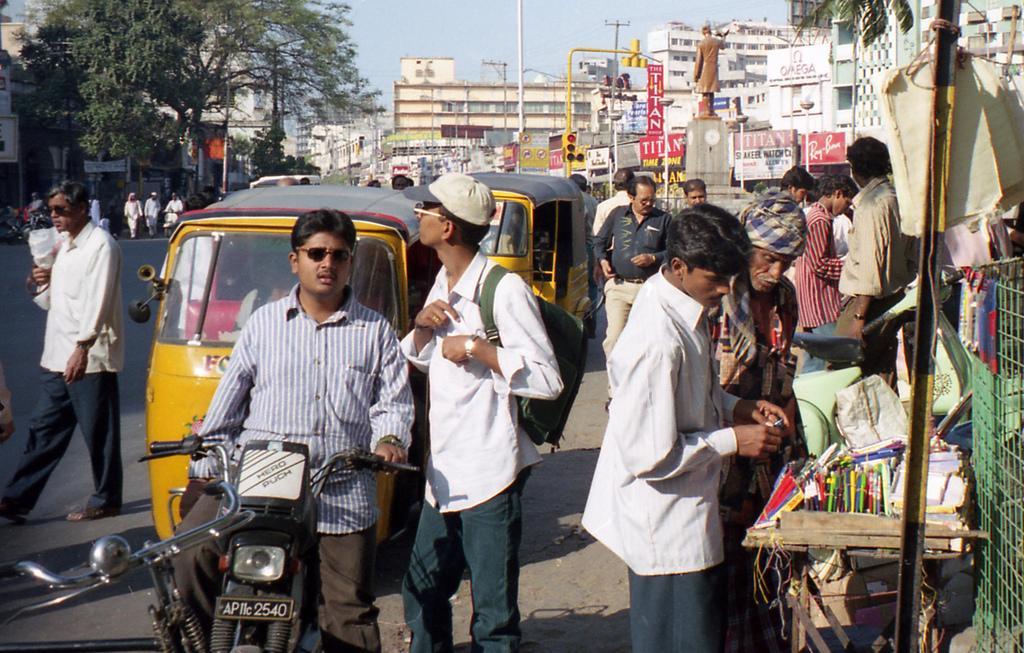In one or two sentences, can you explain what this image depicts? In this image we can see people, vehicles, bike, poles, boards, traffic signal, trees, statue, road, and buildings. In the background there is sky. 